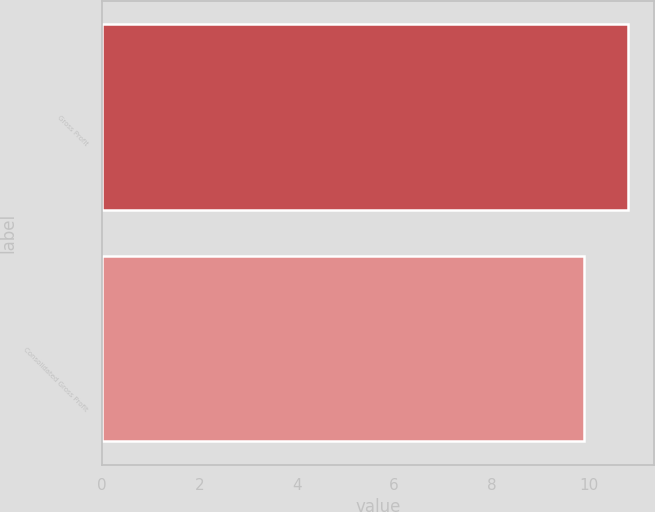<chart> <loc_0><loc_0><loc_500><loc_500><bar_chart><fcel>Gross Profit<fcel>Consolidated Gross Profit<nl><fcel>10.8<fcel>9.9<nl></chart> 